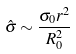Convert formula to latex. <formula><loc_0><loc_0><loc_500><loc_500>\hat { \sigma } \sim \frac { \sigma _ { 0 } r ^ { 2 } } { R ^ { 2 } _ { 0 } }</formula> 